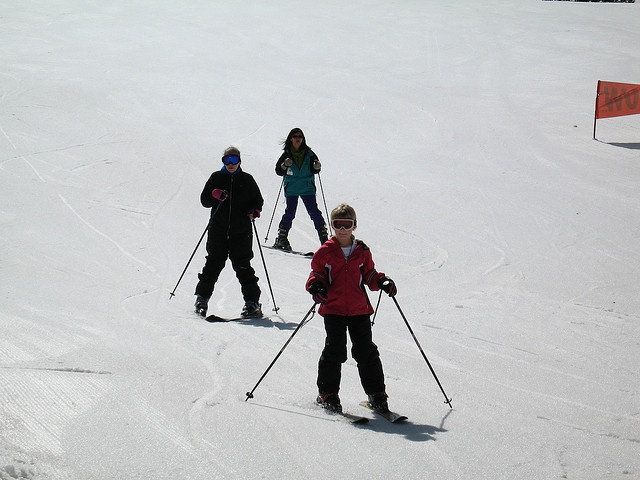Describe the objects in this image and their specific colors. I can see people in lightgray, black, maroon, gray, and darkgray tones, people in lightgray, black, gray, and maroon tones, people in lightgray, black, gray, and darkblue tones, skis in lightgray, black, gray, and darkgray tones, and skis in lightgray, gray, black, and darkgray tones in this image. 